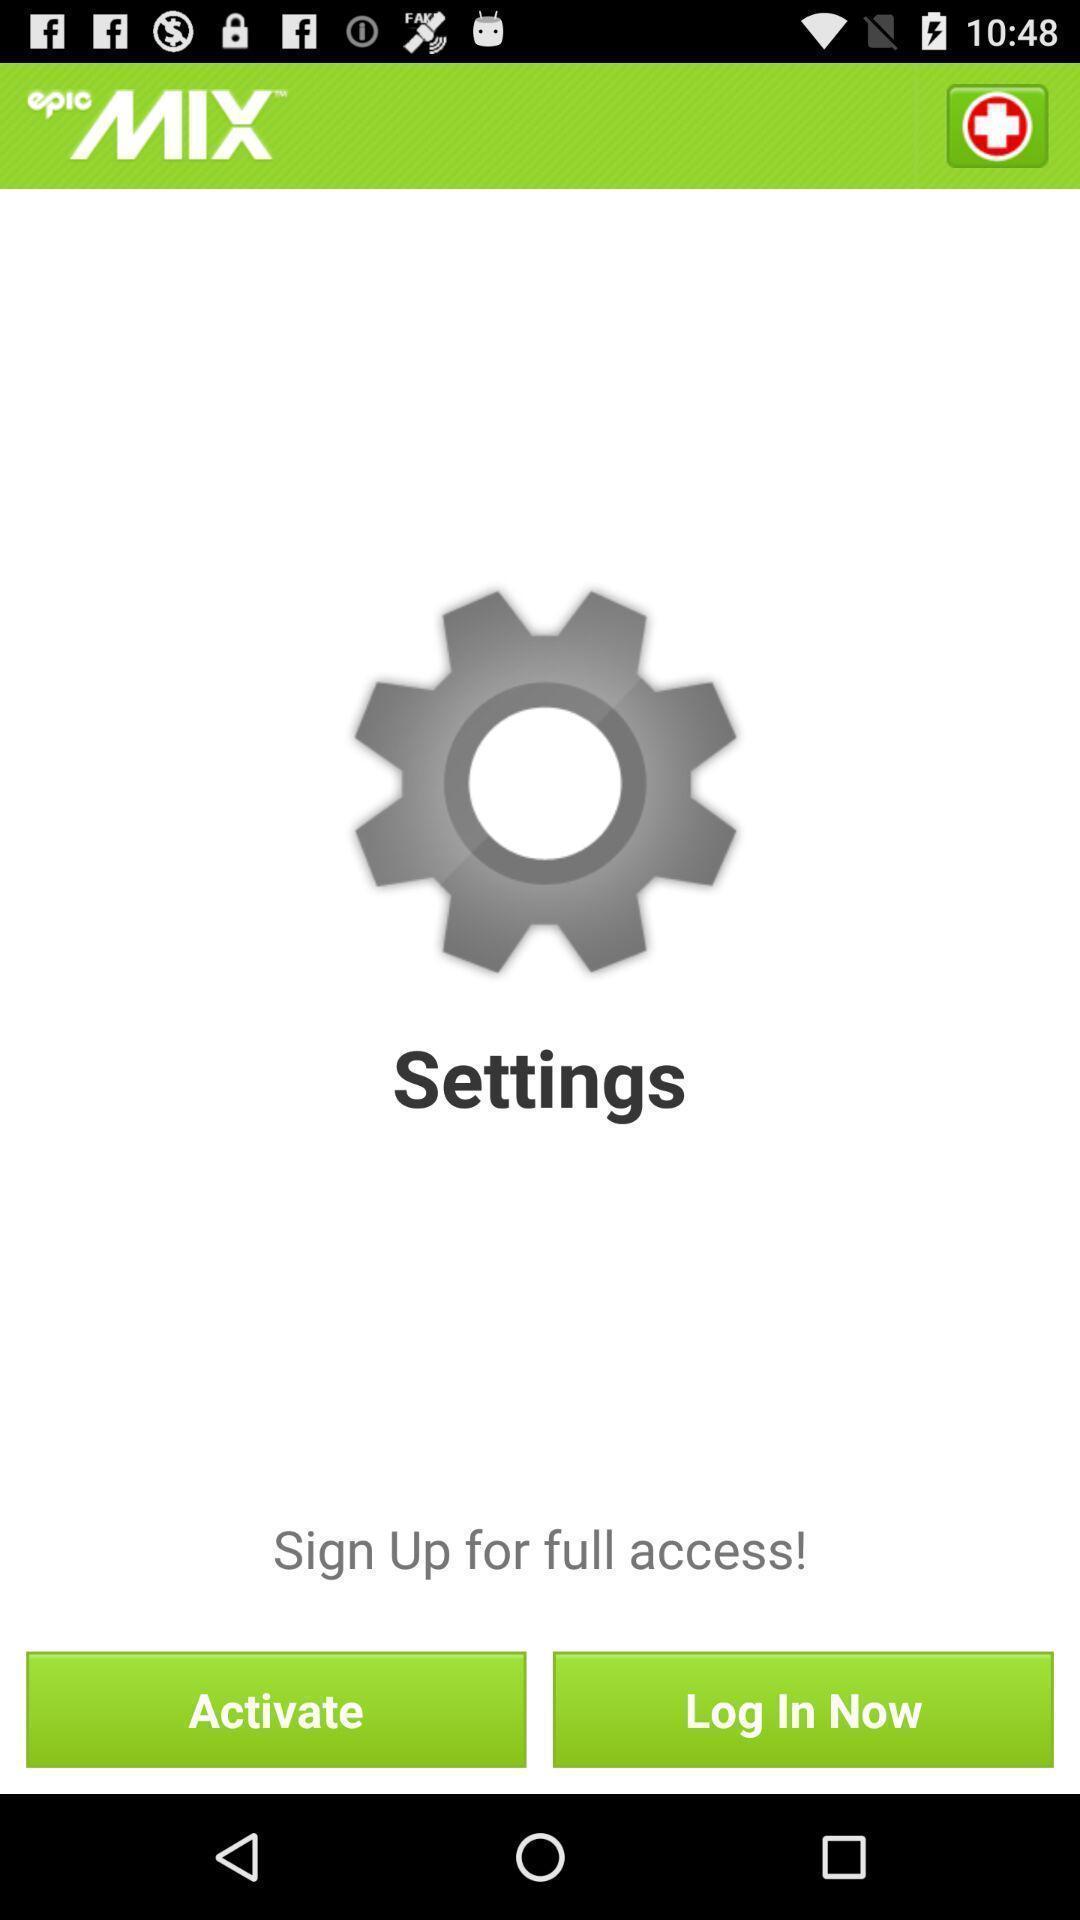Explain what's happening in this screen capture. Sign up page. 